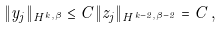<formula> <loc_0><loc_0><loc_500><loc_500>\| y _ { j } \| _ { H ^ { k , \beta } } \leq C \| z _ { j } \| _ { H ^ { k - 2 , \beta - 2 } } = C \, ,</formula> 